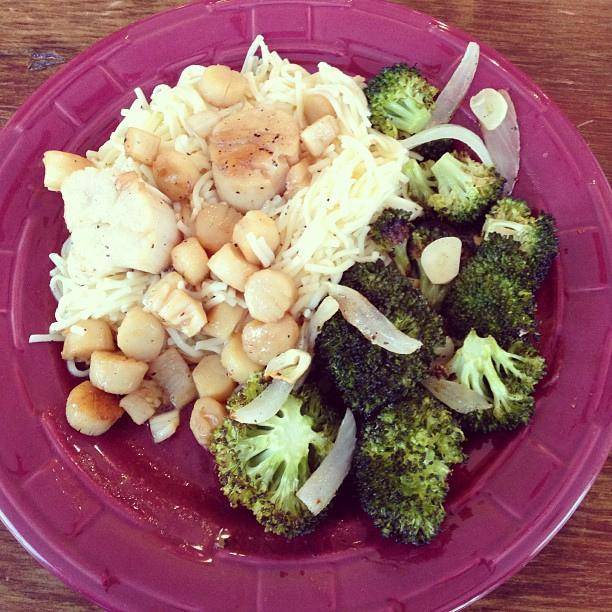What type of seafood is being served?

Choices:
A) scallops
B) shrimp
C) crab
D) fish scallops 